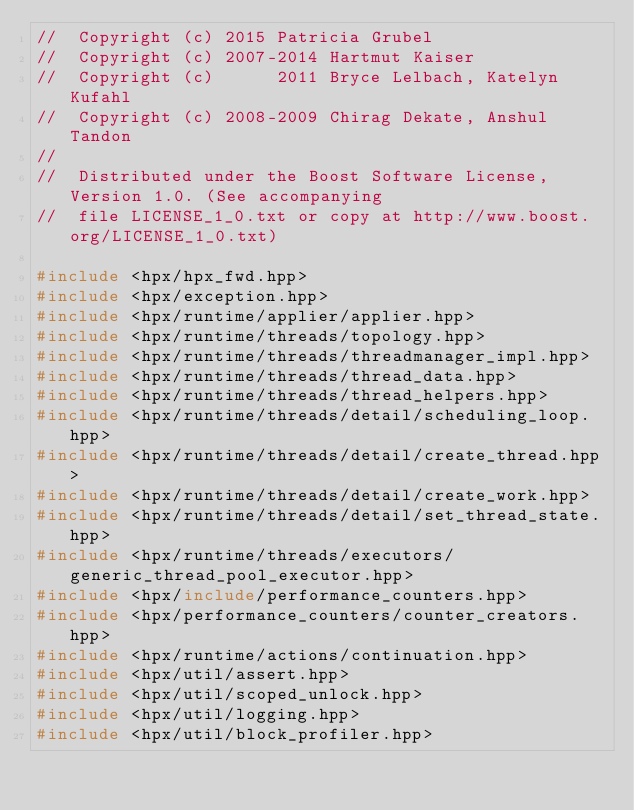<code> <loc_0><loc_0><loc_500><loc_500><_C++_>//  Copyright (c) 2015 Patricia Grubel
//  Copyright (c) 2007-2014 Hartmut Kaiser
//  Copyright (c)      2011 Bryce Lelbach, Katelyn Kufahl
//  Copyright (c) 2008-2009 Chirag Dekate, Anshul Tandon
//
//  Distributed under the Boost Software License, Version 1.0. (See accompanying
//  file LICENSE_1_0.txt or copy at http://www.boost.org/LICENSE_1_0.txt)

#include <hpx/hpx_fwd.hpp>
#include <hpx/exception.hpp>
#include <hpx/runtime/applier/applier.hpp>
#include <hpx/runtime/threads/topology.hpp>
#include <hpx/runtime/threads/threadmanager_impl.hpp>
#include <hpx/runtime/threads/thread_data.hpp>
#include <hpx/runtime/threads/thread_helpers.hpp>
#include <hpx/runtime/threads/detail/scheduling_loop.hpp>
#include <hpx/runtime/threads/detail/create_thread.hpp>
#include <hpx/runtime/threads/detail/create_work.hpp>
#include <hpx/runtime/threads/detail/set_thread_state.hpp>
#include <hpx/runtime/threads/executors/generic_thread_pool_executor.hpp>
#include <hpx/include/performance_counters.hpp>
#include <hpx/performance_counters/counter_creators.hpp>
#include <hpx/runtime/actions/continuation.hpp>
#include <hpx/util/assert.hpp>
#include <hpx/util/scoped_unlock.hpp>
#include <hpx/util/logging.hpp>
#include <hpx/util/block_profiler.hpp></code> 